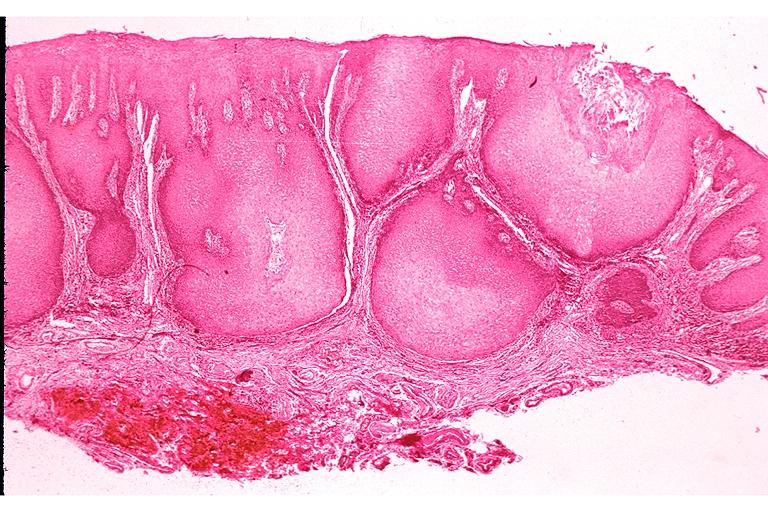does this image show verrucous carcinoma?
Answer the question using a single word or phrase. Yes 